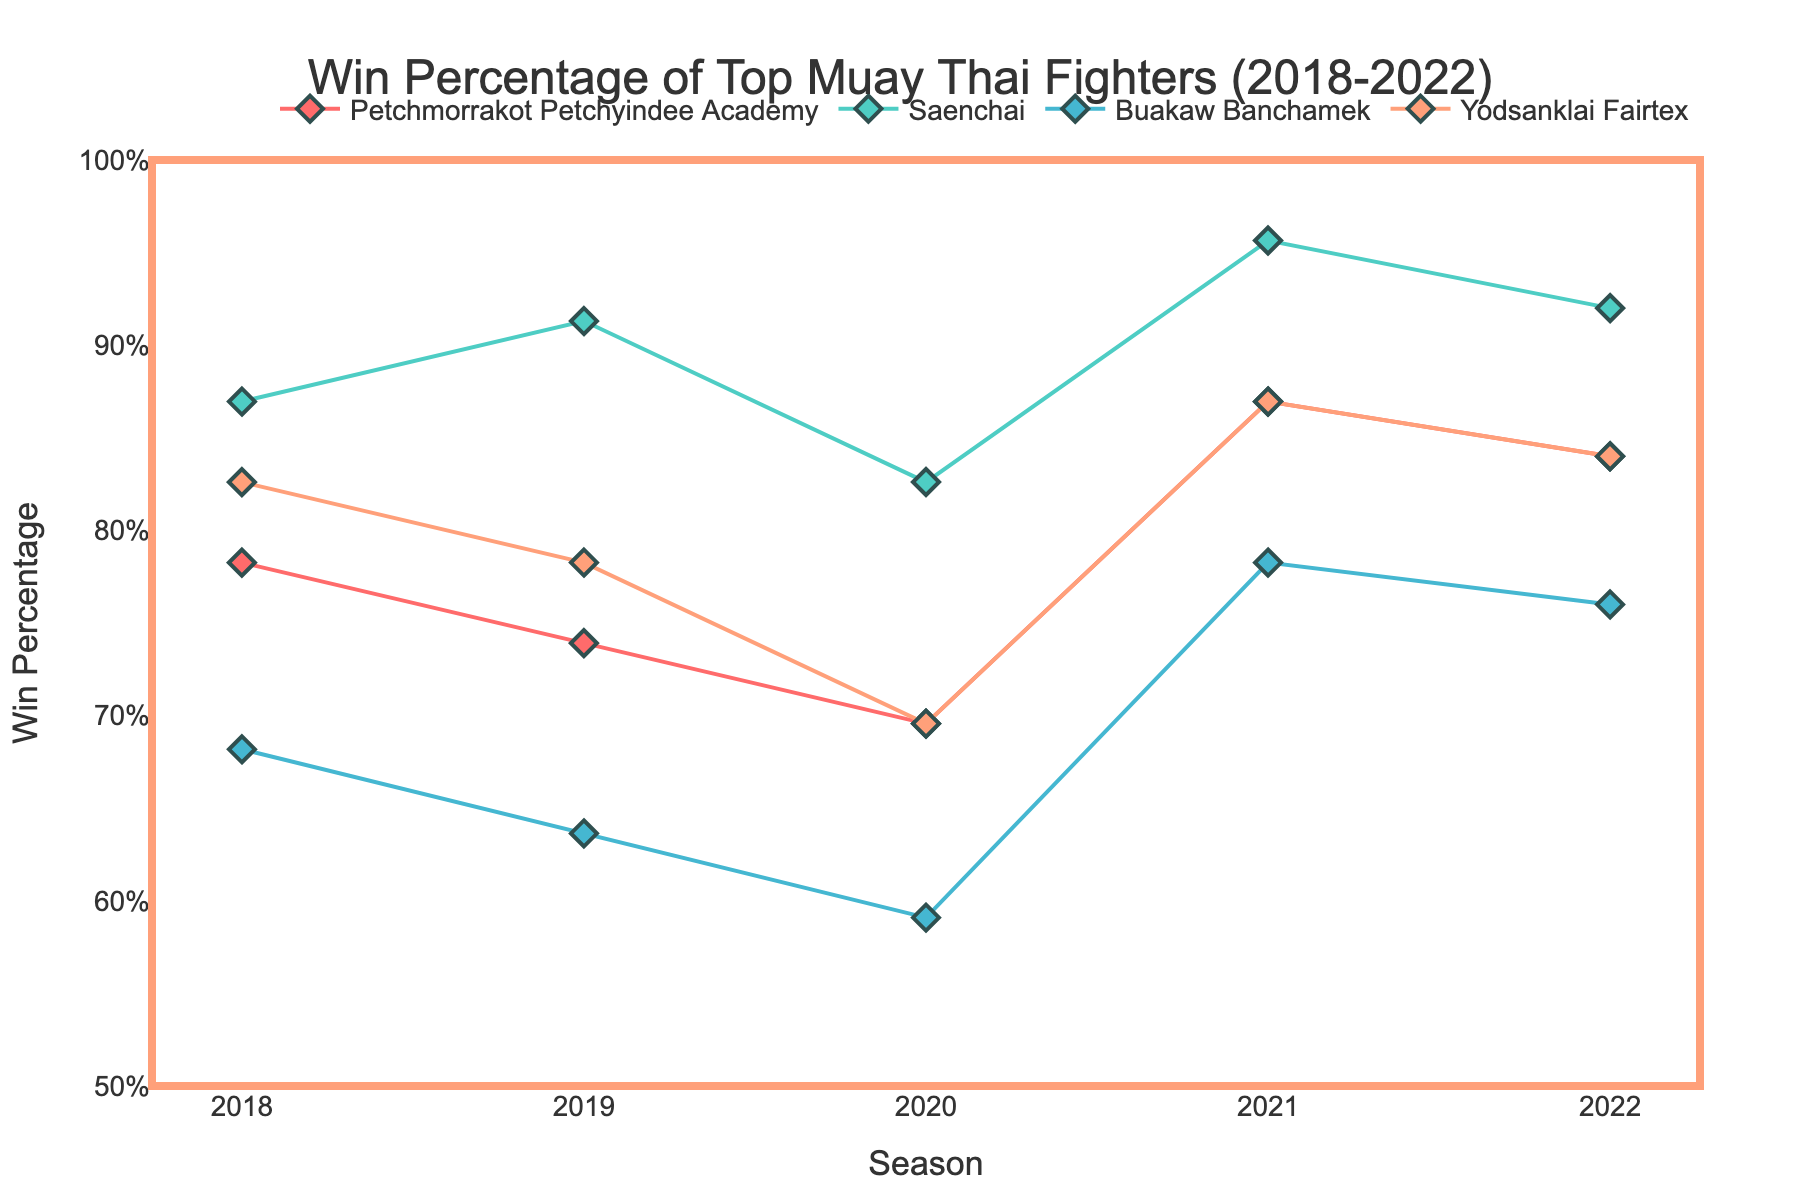What's the title of the figure? The title of the figure is located at the top and typically succinctly describes the main topic or observation represented by the graph. This figure's title reads "Win Percentage of Top Muay Thai Fighters (2018-2022)."
Answer: Win Percentage of Top Muay Thai Fighters (2018-2022) How many fighters are represented in the plot? By looking at the legend and the lines in different colors, we see that four fighters are represented: Petchmorrakot Petchyindee Academy, Saenchai, Buakaw Banchamek, and Yodsanklai Fairtex.
Answer: 4 What color represents Saenchai? The legend uses different colors to represent each fighter. According to the legend, Saenchai is represented by the color turquoise.
Answer: Turquoise In which season did Buakaw Banchamek have the lowest win percentage? By examining the graph and focusing on Buakaw Banchamek's line (light blue), we see that his lowest win percentage occurred in the 2020 season.
Answer: 2020 Which fighter had the highest win percentage in 2021? To answer this, we need to scan the 2021 season on the x-axis and identify the highest point. Saenchai's line (turquoise) reaches the highest point, indicating the highest win percentage in 2021.
Answer: Saenchai How many win percentages fall above 85% throughout all seasons? By evaluating the y-axis range and counting the points above the 85% mark across all seasons for all fighters, we find 8 instances.
Answer: 8 What is the general trend for Petchmorrakot Petchyindee Academy's win percentage from 2018 to 2022? Observing Petchmorrakot Petchyindee Academy's line (red), the win percentage trends upward from 2018 to 2022, showing a general increase.
Answer: Increasing By how much did Yodsanklai Fairtex’s win percentage change from 2018 to 2019? Locate the points for Yodsanklai Fairtex (orange) in 2018 and 2019, then subtract the 2018 win percentage (~82.6%) from the 2019 win percentage (~78.3%). The change is 4.3%.
Answer: 4.3% Compare the win percentage change between Buakaw Banchamek and Saenchai from 2021 to 2022. Who improved more? Identify the change by subtracting the 2021 win percentage from the 2022 win percentage for both fighters. Buakaw Banchamek's win percentage goes from ~78.3% to ~76%, a slight decrease. Saenchai’s goes from ~95.6% to ~92%, a decrease. Neither improved, but Saenchai's decrease was smaller.
Answer: Saenchai What is the win percentage of Yodsanklai Fairtex in 2020? Locate Yodsanklai Fairtex's win percentage for the 2020 season on the graph. The point lies at approximately 69.6%.
Answer: 69.6% 